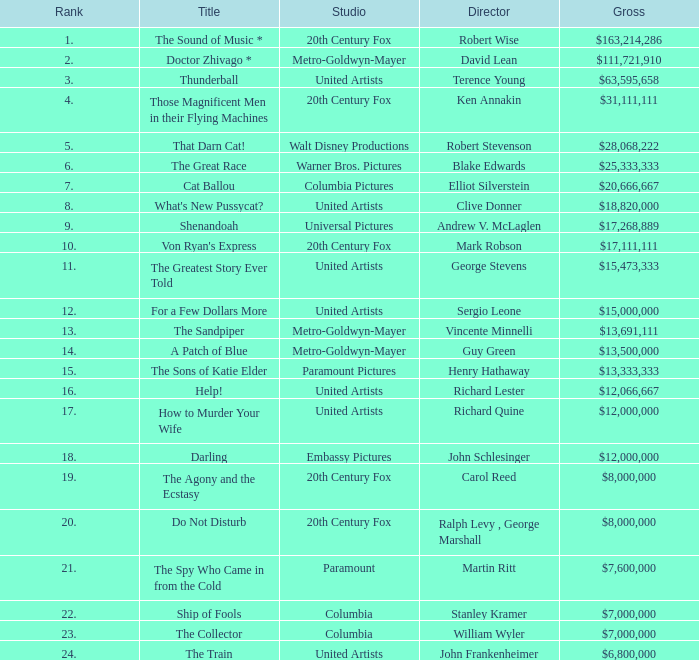What is the heading, when the studio is "embassy pictures"? Darling. 